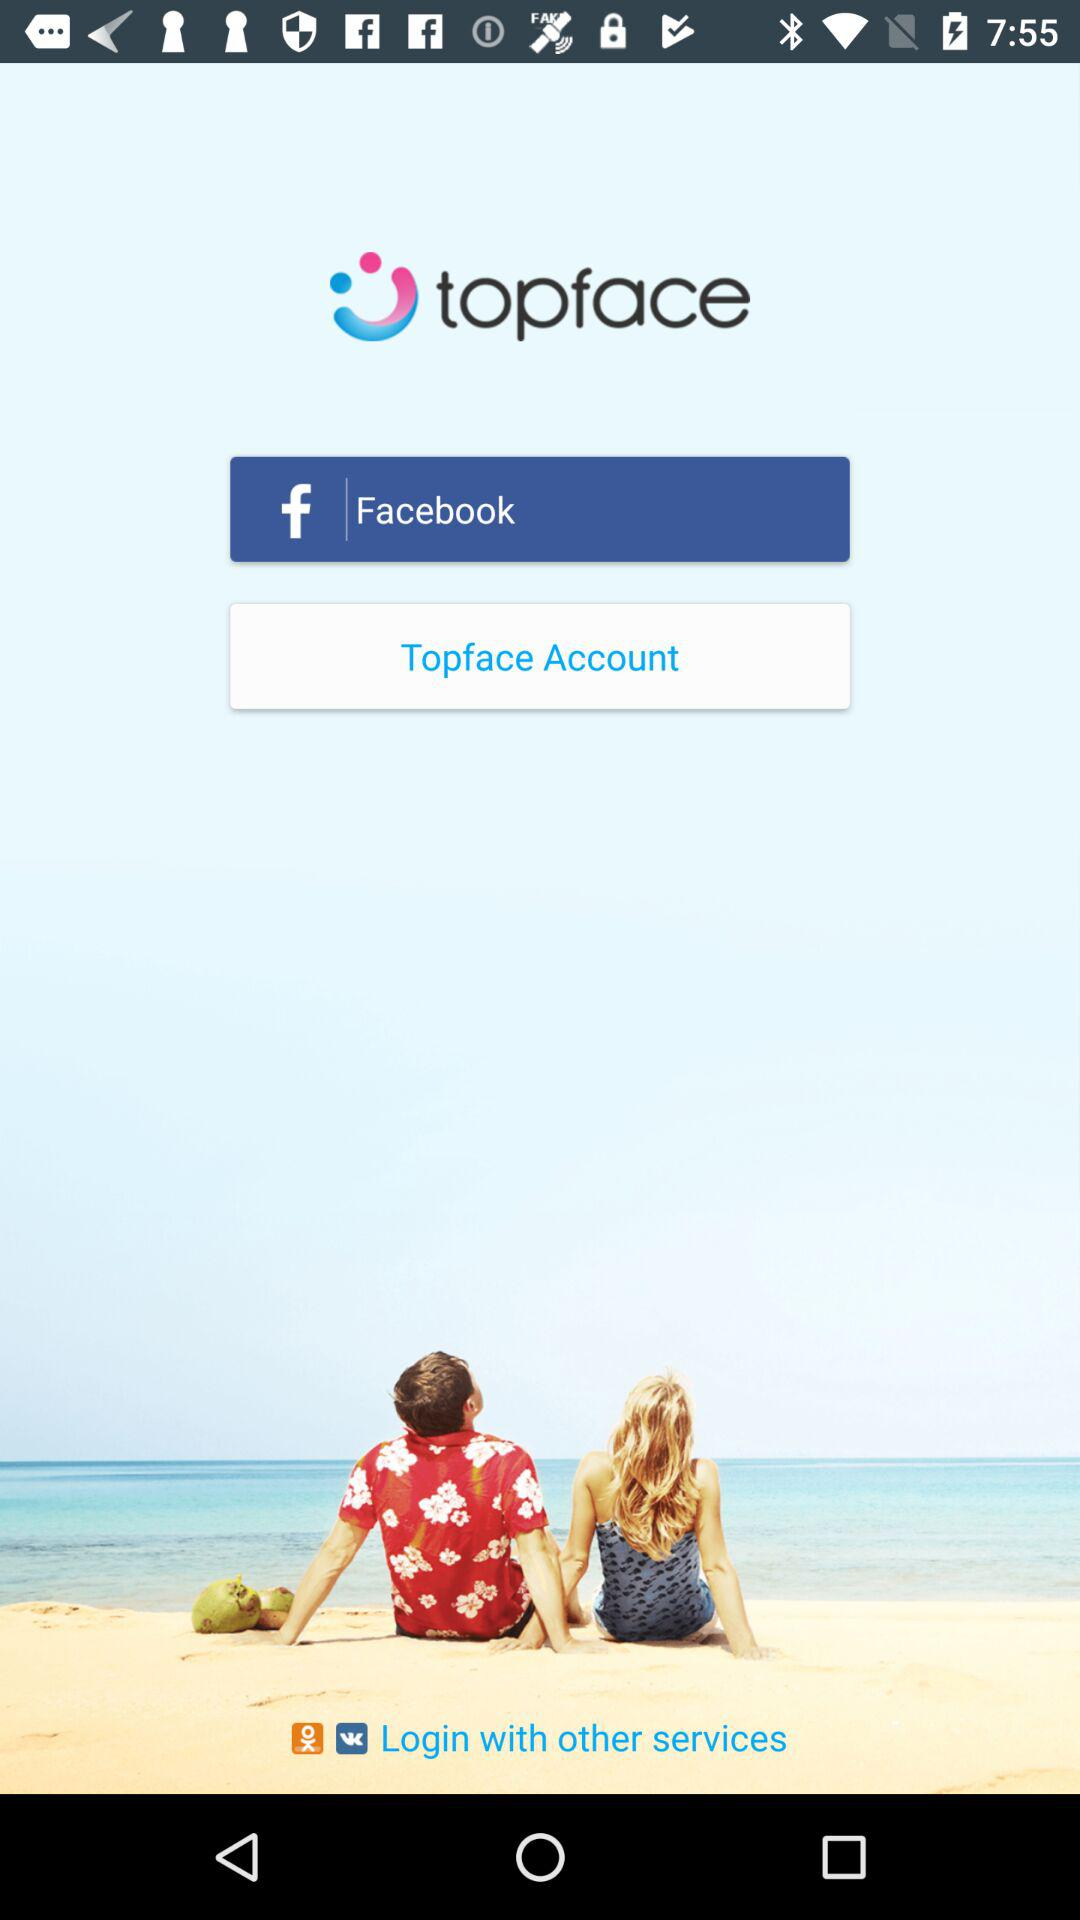What is the application name? The application name is "topface". 